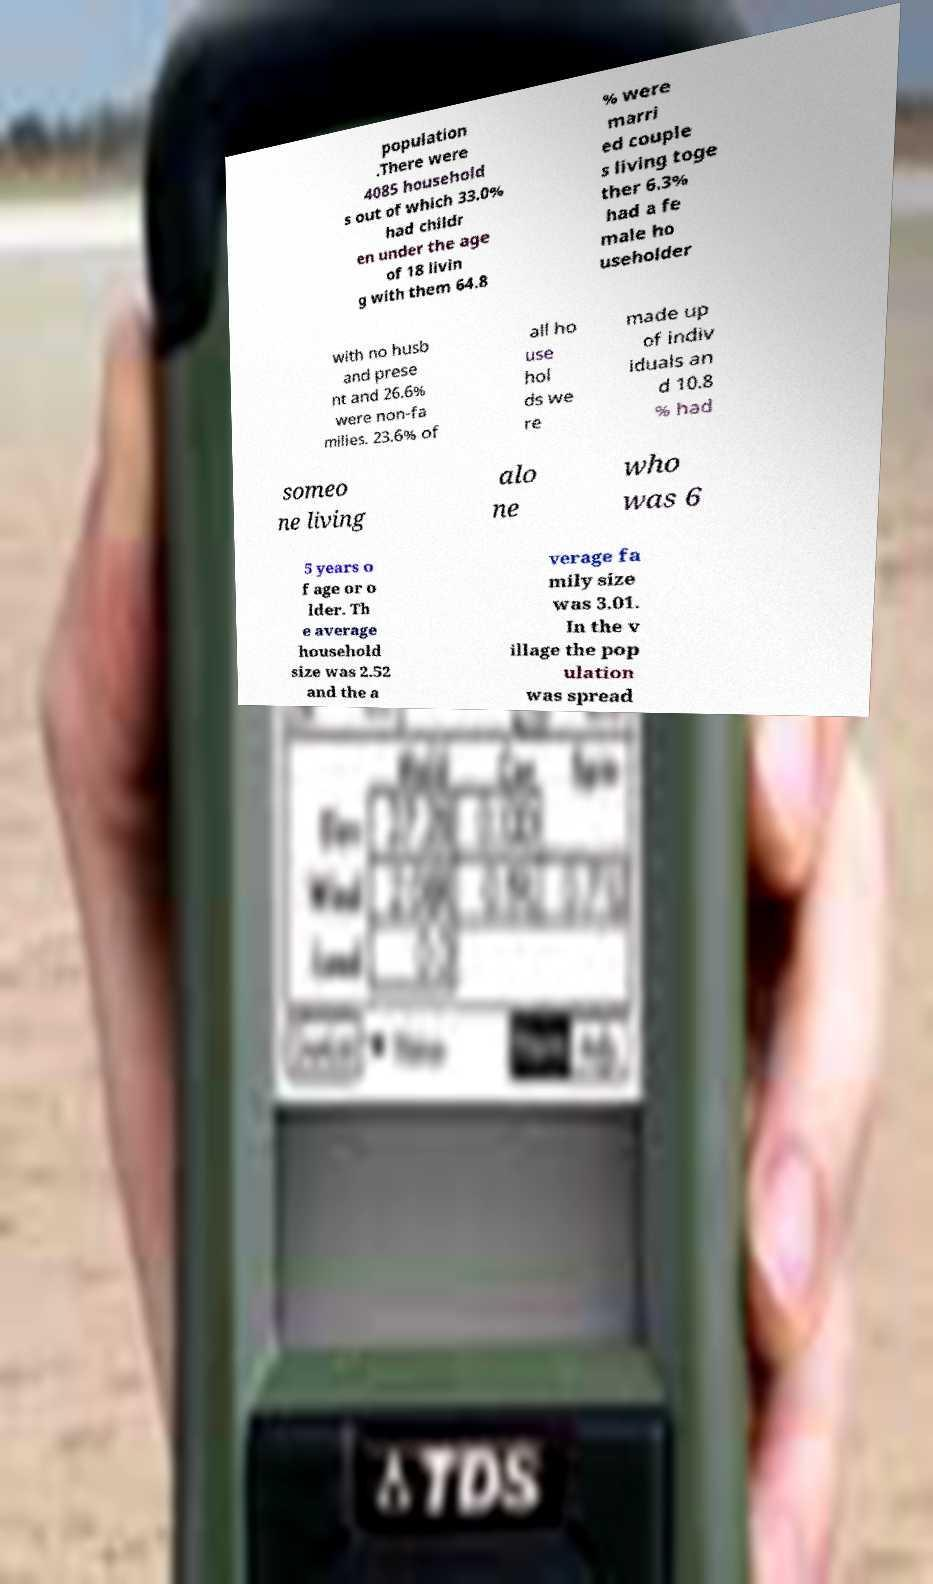Could you assist in decoding the text presented in this image and type it out clearly? population .There were 4085 household s out of which 33.0% had childr en under the age of 18 livin g with them 64.8 % were marri ed couple s living toge ther 6.3% had a fe male ho useholder with no husb and prese nt and 26.6% were non-fa milies. 23.6% of all ho use hol ds we re made up of indiv iduals an d 10.8 % had someo ne living alo ne who was 6 5 years o f age or o lder. Th e average household size was 2.52 and the a verage fa mily size was 3.01. In the v illage the pop ulation was spread 